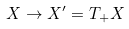<formula> <loc_0><loc_0><loc_500><loc_500>X \to X ^ { \prime } = T _ { + } X</formula> 